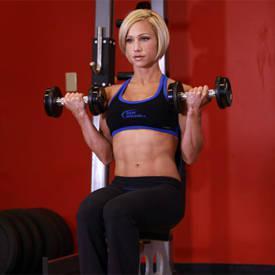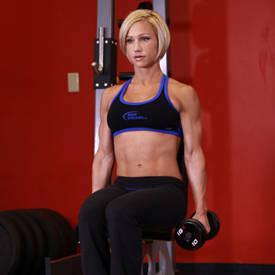The first image is the image on the left, the second image is the image on the right. Given the left and right images, does the statement "At least one woman is featured." hold true? Answer yes or no. Yes. 